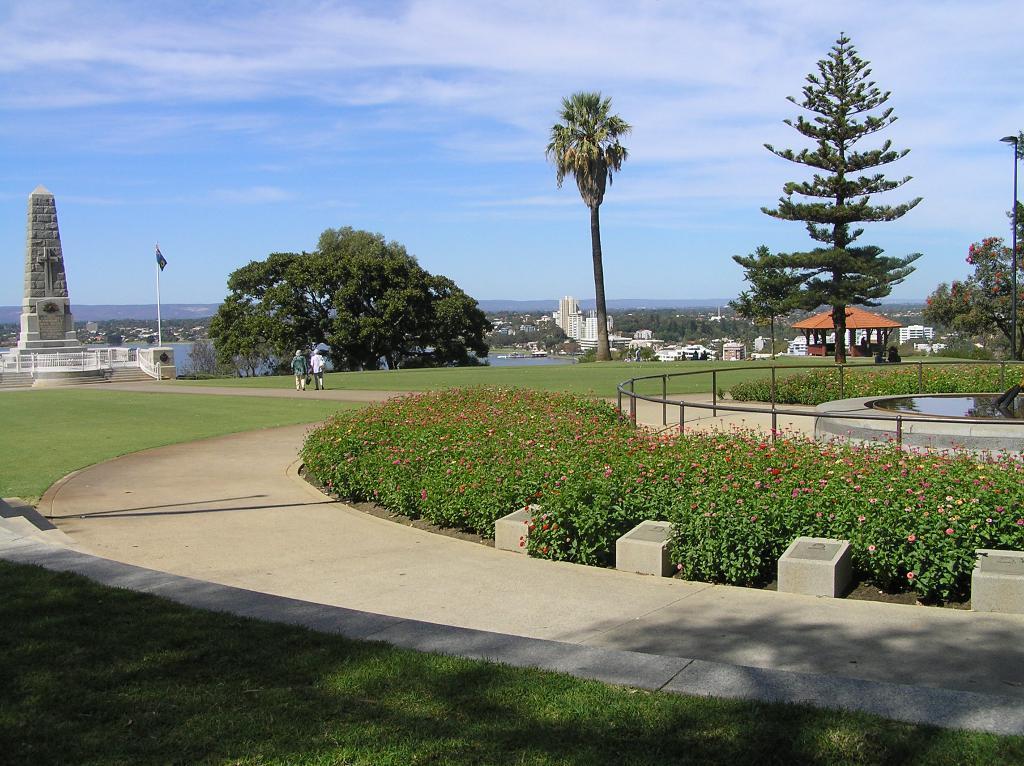In one or two sentences, can you explain what this image depicts? In the picture we can see a pathway and inside we can see a grass surface and on the other side, we can see some plants with some small flowers and near to it, we can see a railing and a fountain and in the background, we can see two persons are walking on the path and behind them, we can see a sculpted pillar and besides, we can see a flag to the pole and trees and behind it we can see a water and far away from it we can see trees, buildings, and sky. 